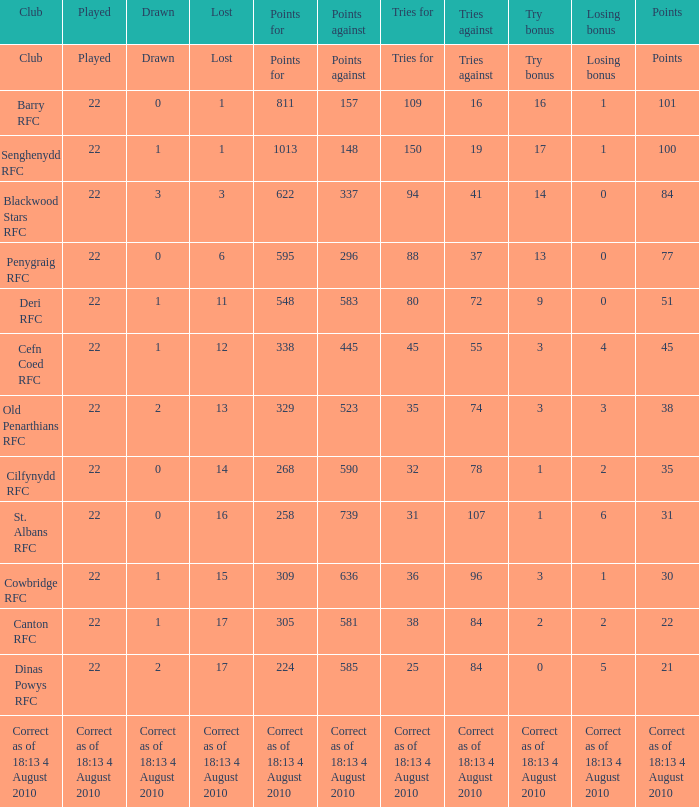What was the loss experienced when it was barry rfc? 1.0. 